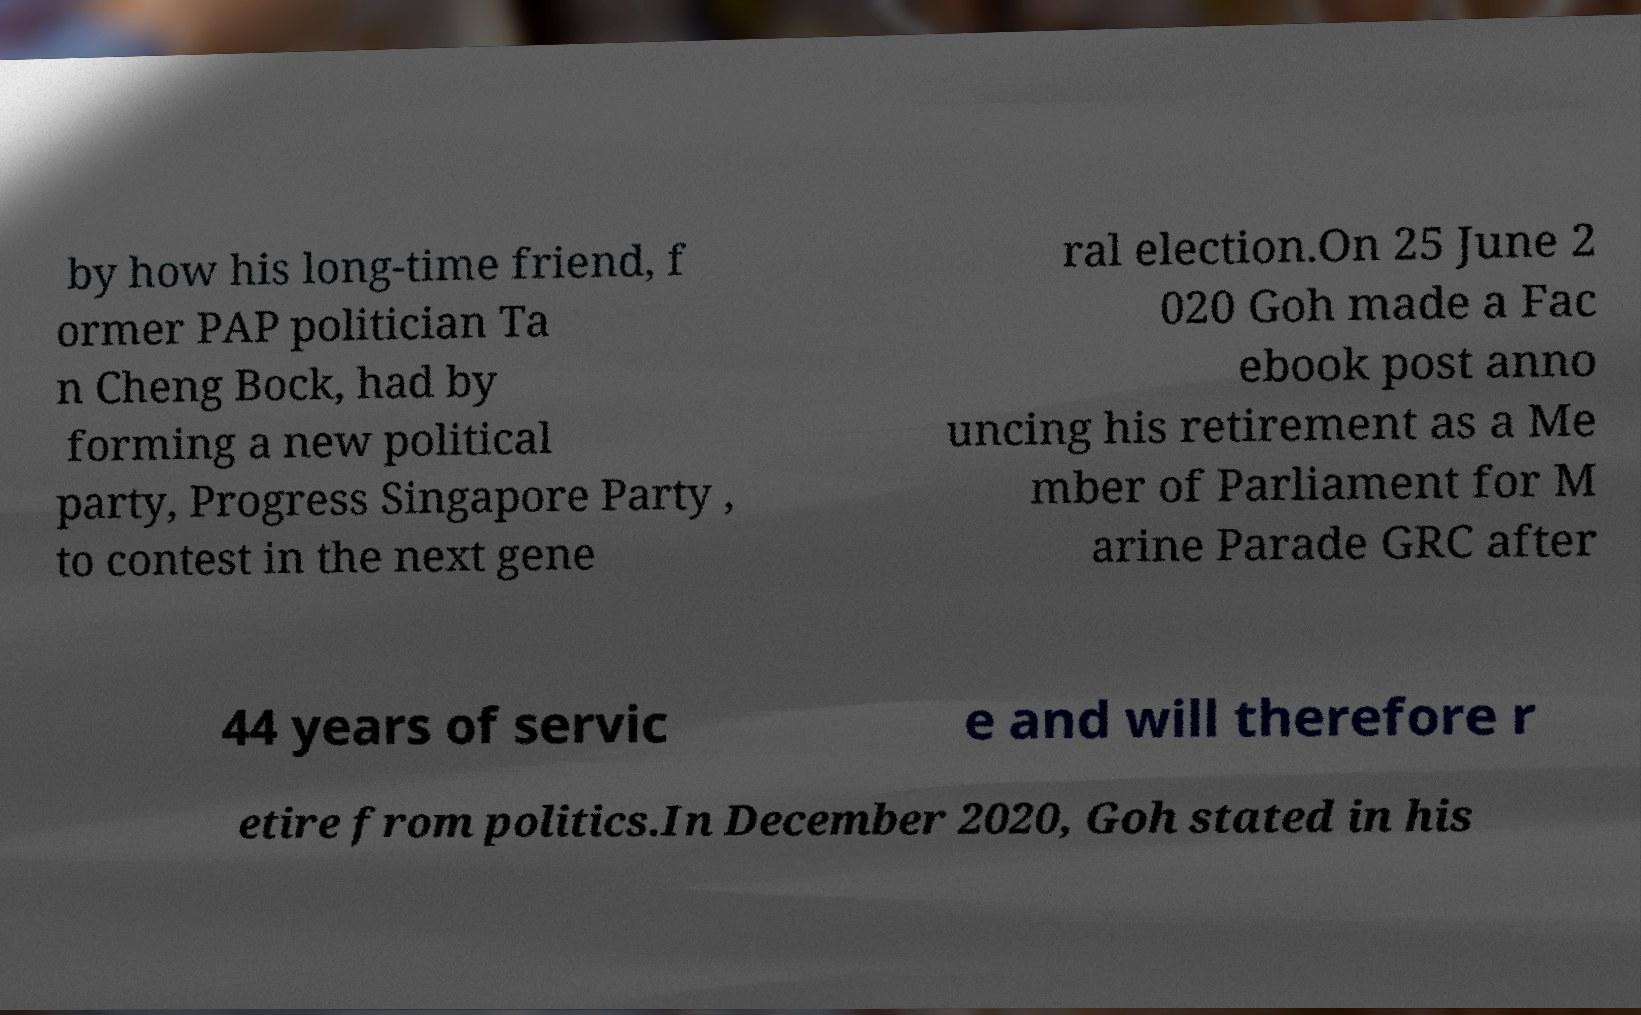I need the written content from this picture converted into text. Can you do that? by how his long-time friend, f ormer PAP politician Ta n Cheng Bock, had by forming a new political party, Progress Singapore Party , to contest in the next gene ral election.On 25 June 2 020 Goh made a Fac ebook post anno uncing his retirement as a Me mber of Parliament for M arine Parade GRC after 44 years of servic e and will therefore r etire from politics.In December 2020, Goh stated in his 